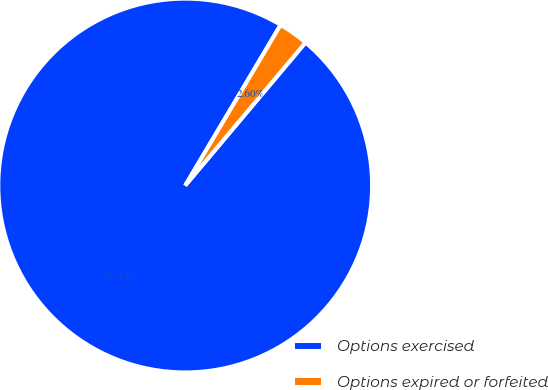<chart> <loc_0><loc_0><loc_500><loc_500><pie_chart><fcel>Options exercised<fcel>Options expired or forfeited<nl><fcel>97.4%<fcel>2.6%<nl></chart> 